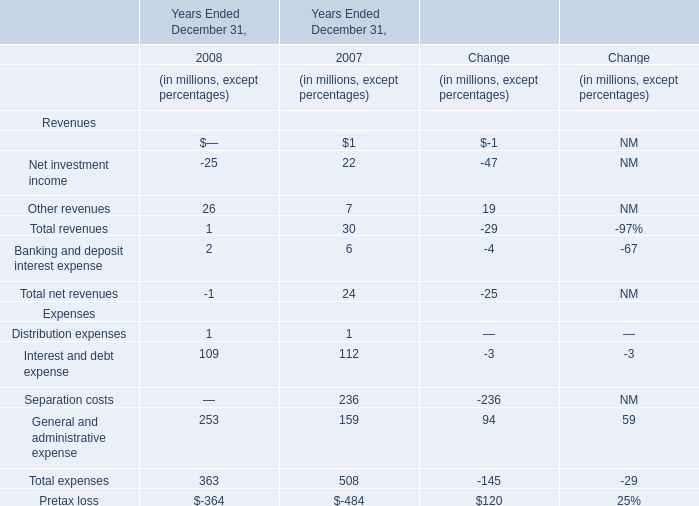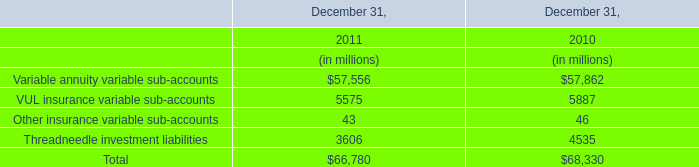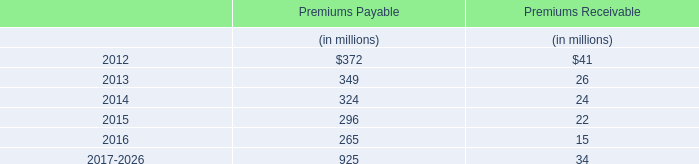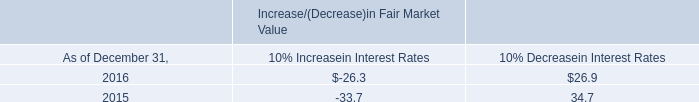what is the statistical interval for 2017's interest income using 2016's interest income as a midpoint? 
Computations: (20.1 - 11.0)
Answer: 9.1. 